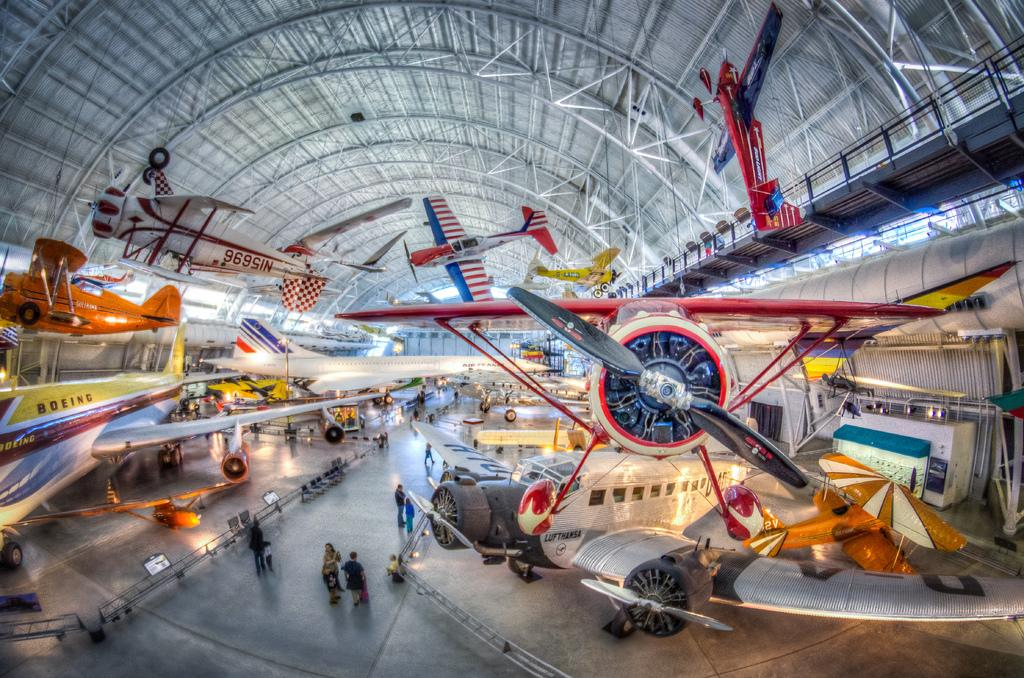What objects are on the floor in the image? There are aeroplanes on the floor and hanging from the ceiling in the image. What are the people in the image doing? The people in the image are walking. Where are most of the people located in the image? Most of the people are located on the middle path in the image. What type of location might this image depict? The setting appears to be an aircraft museum. What flavor of toothpaste is being used by the people in the image? There is no toothpaste present in the image, and therefore no such activity can be observed. 